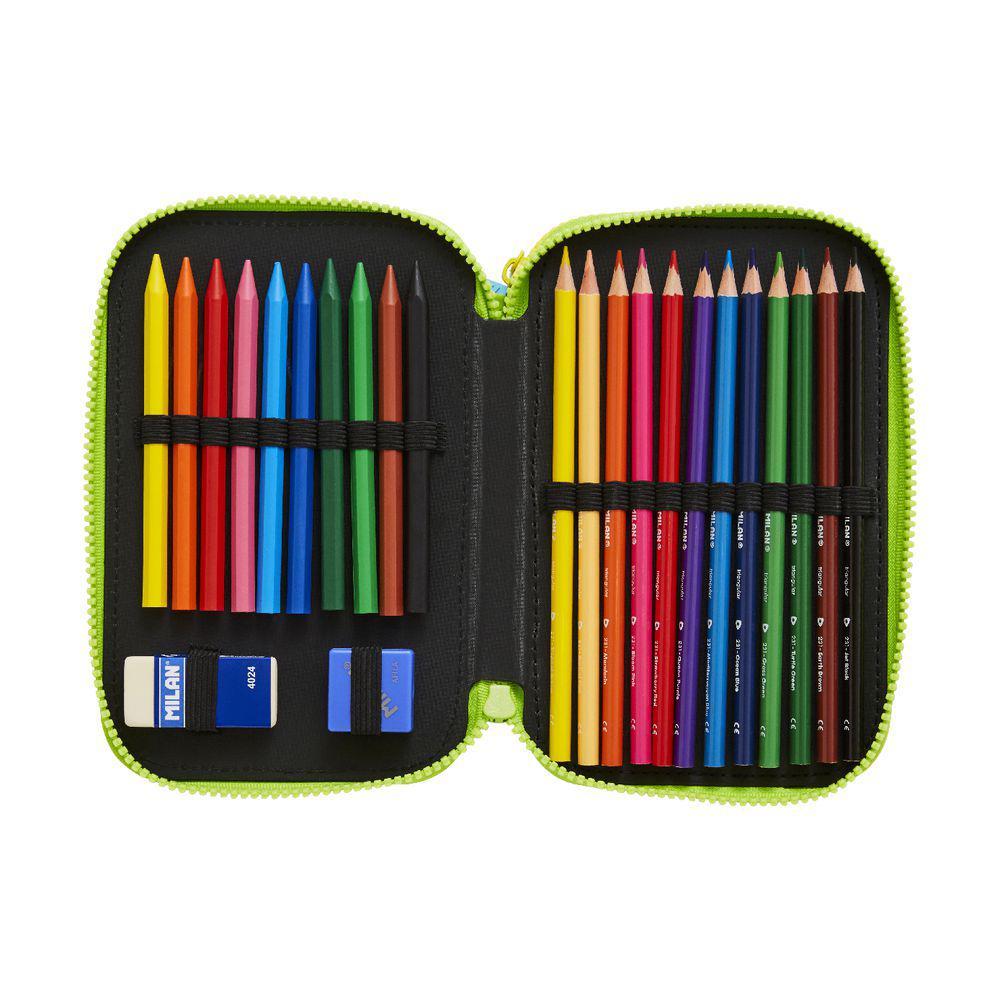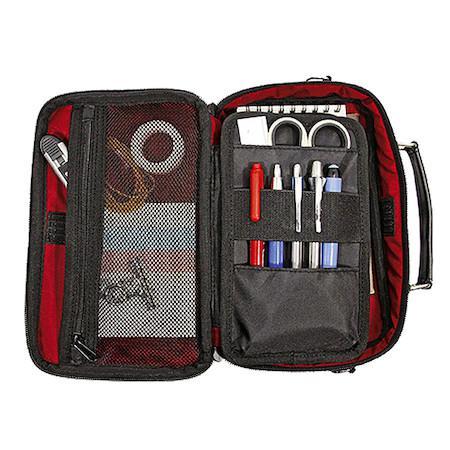The first image is the image on the left, the second image is the image on the right. Given the left and right images, does the statement "There is at least one pair of scissors inside of the binder in one of the images." hold true? Answer yes or no. Yes. The first image is the image on the left, the second image is the image on the right. Analyze the images presented: Is the assertion "One container has a pair of scissors." valid? Answer yes or no. Yes. 